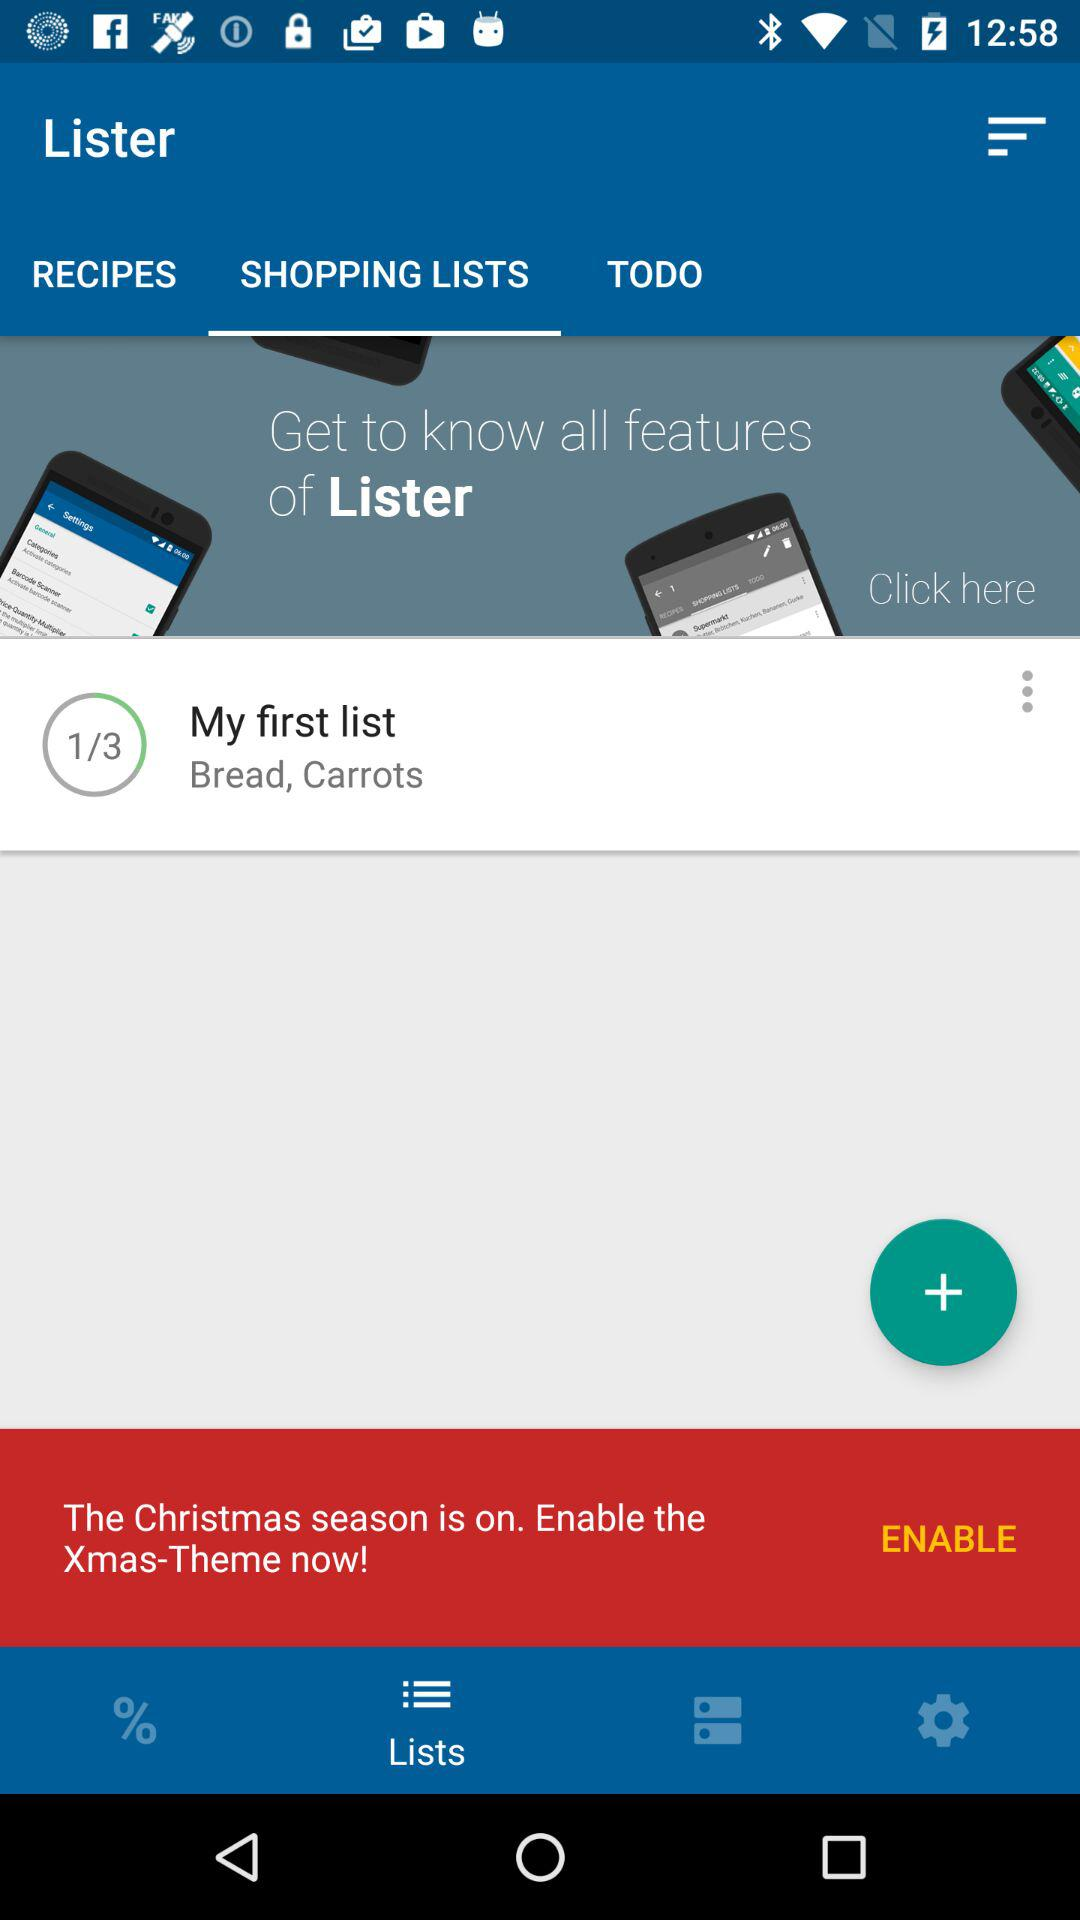What is the status of the Christmas theme now?
When the provided information is insufficient, respond with <no answer>. <no answer> 